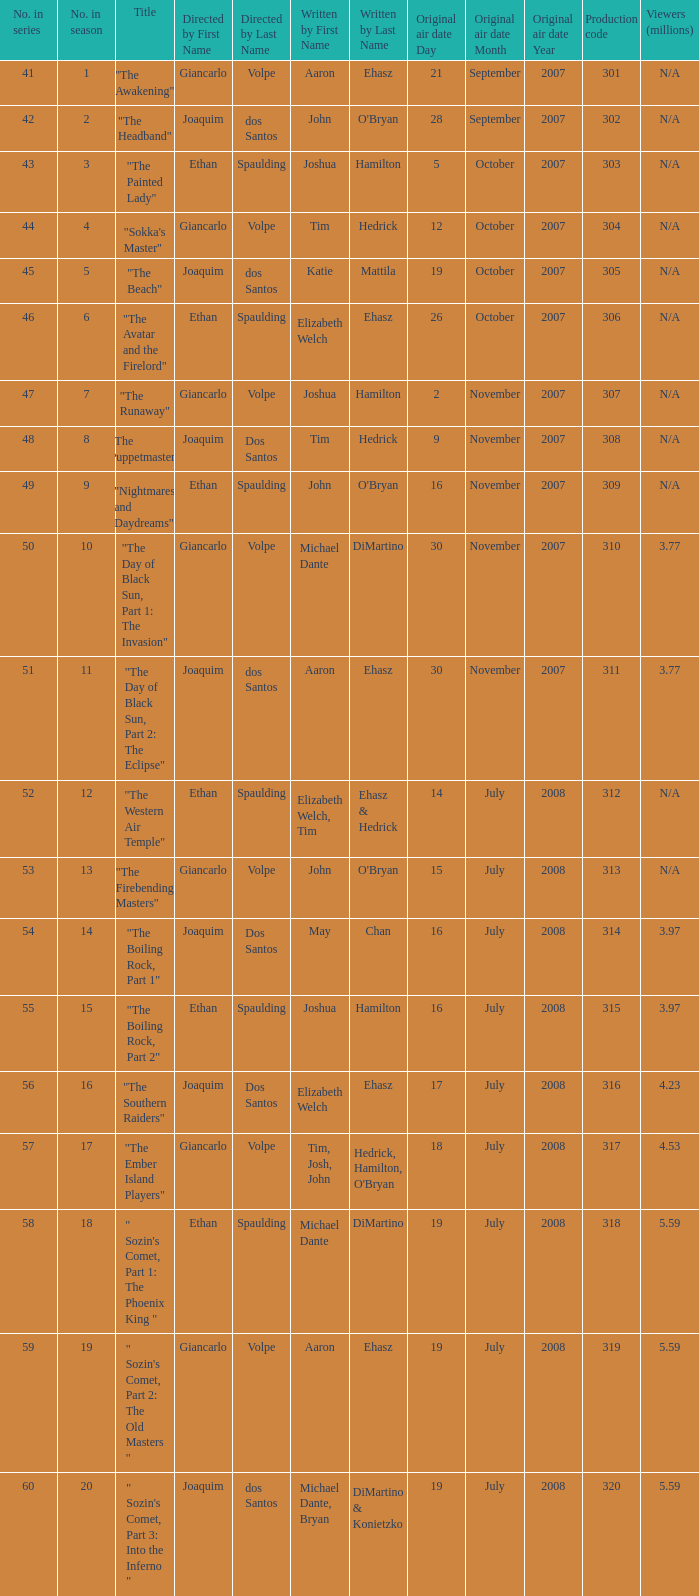What is the original air date for the episode with a production code of 318? July19,2008. 